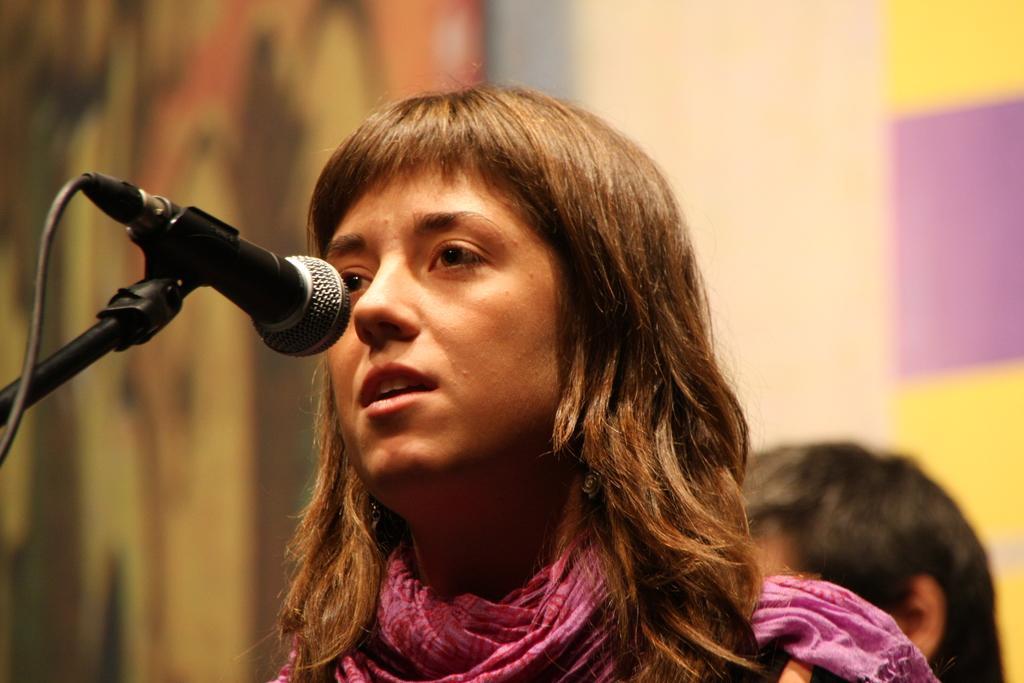How would you summarize this image in a sentence or two? In this image I can see a woman wearing pink colored dress and a microphone which is black and silver in color. In the background I can see another person and few blurry surfaces. 